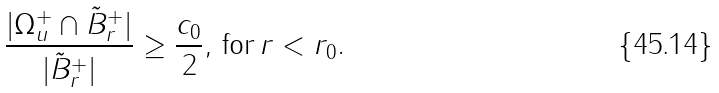Convert formula to latex. <formula><loc_0><loc_0><loc_500><loc_500>\frac { | \Omega _ { u } ^ { + } \cap { \tilde { B } } ^ { + } _ { r } | } { | { \tilde { B } } ^ { + } _ { r } | } \geq \frac { c _ { 0 } } { 2 } , \, \text {for} \, r < r _ { 0 } .</formula> 